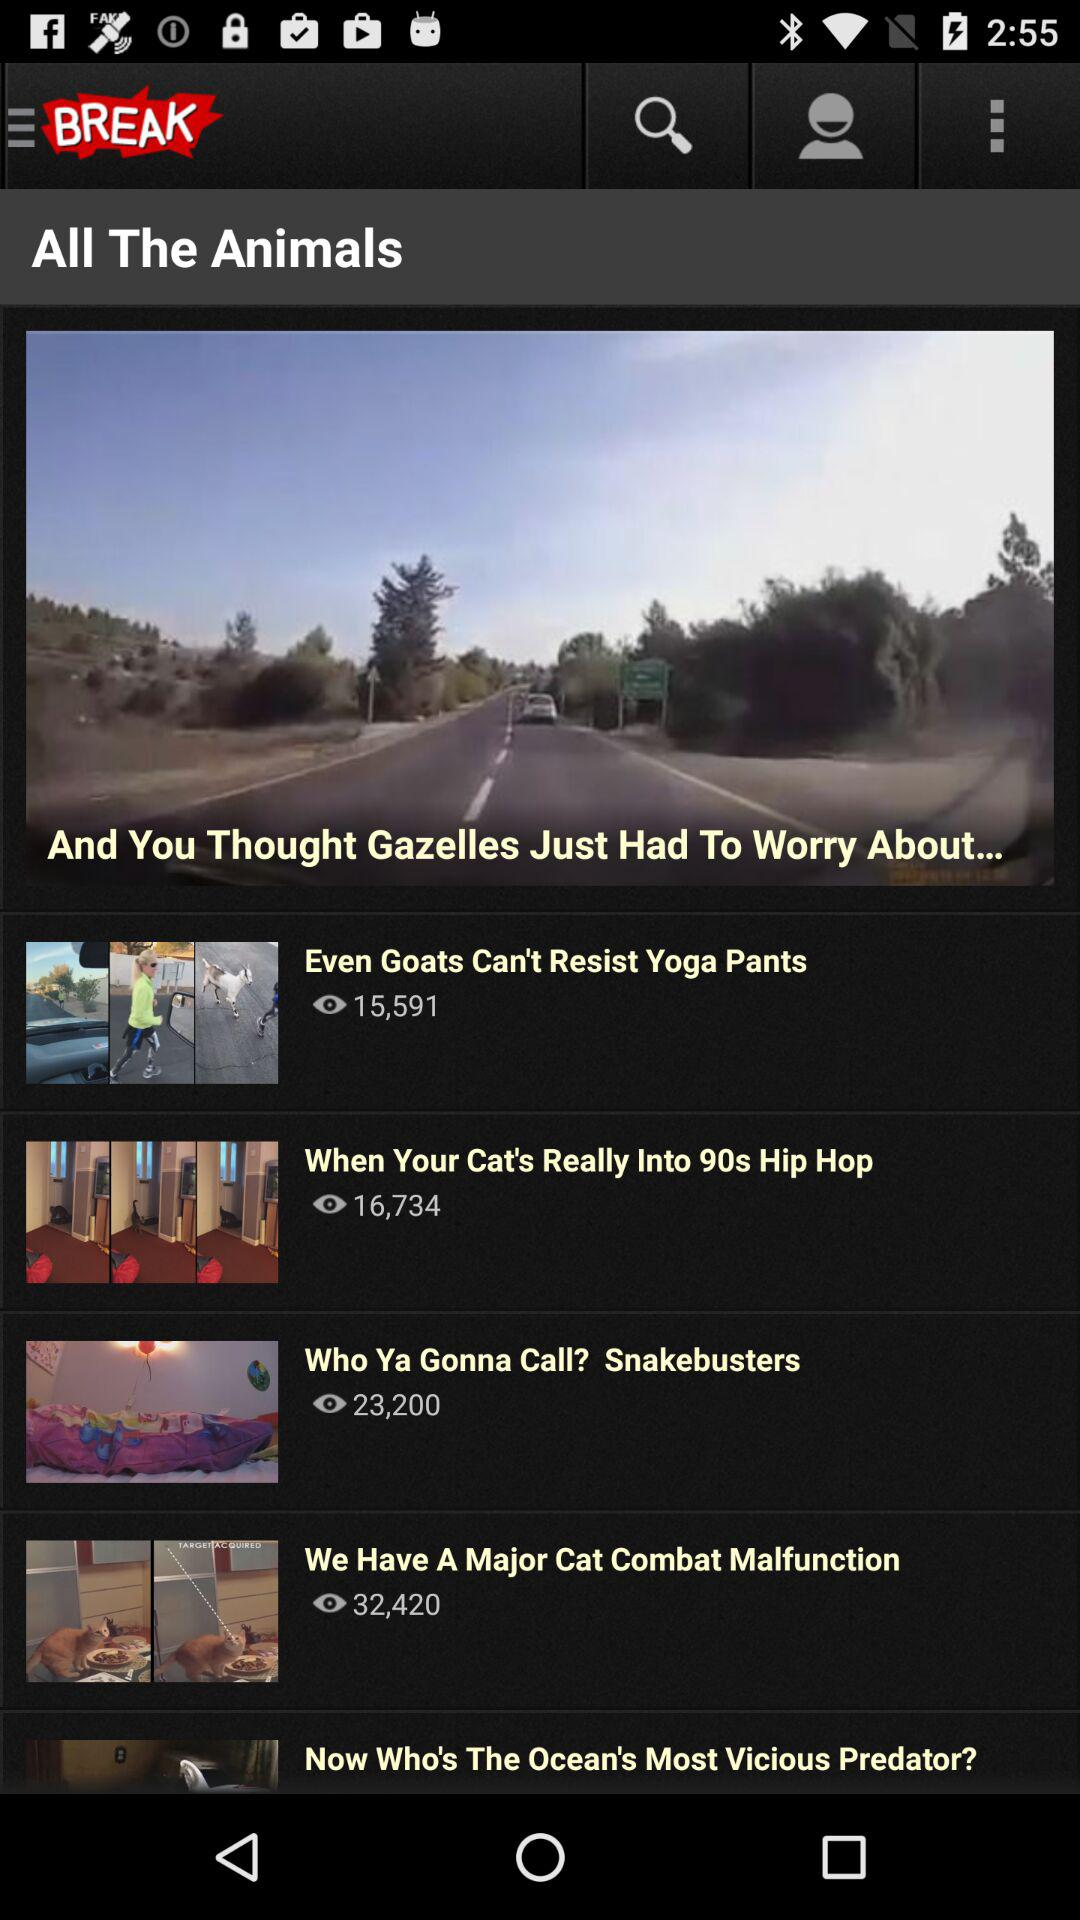What is the app name? The app name is "BREAK". 